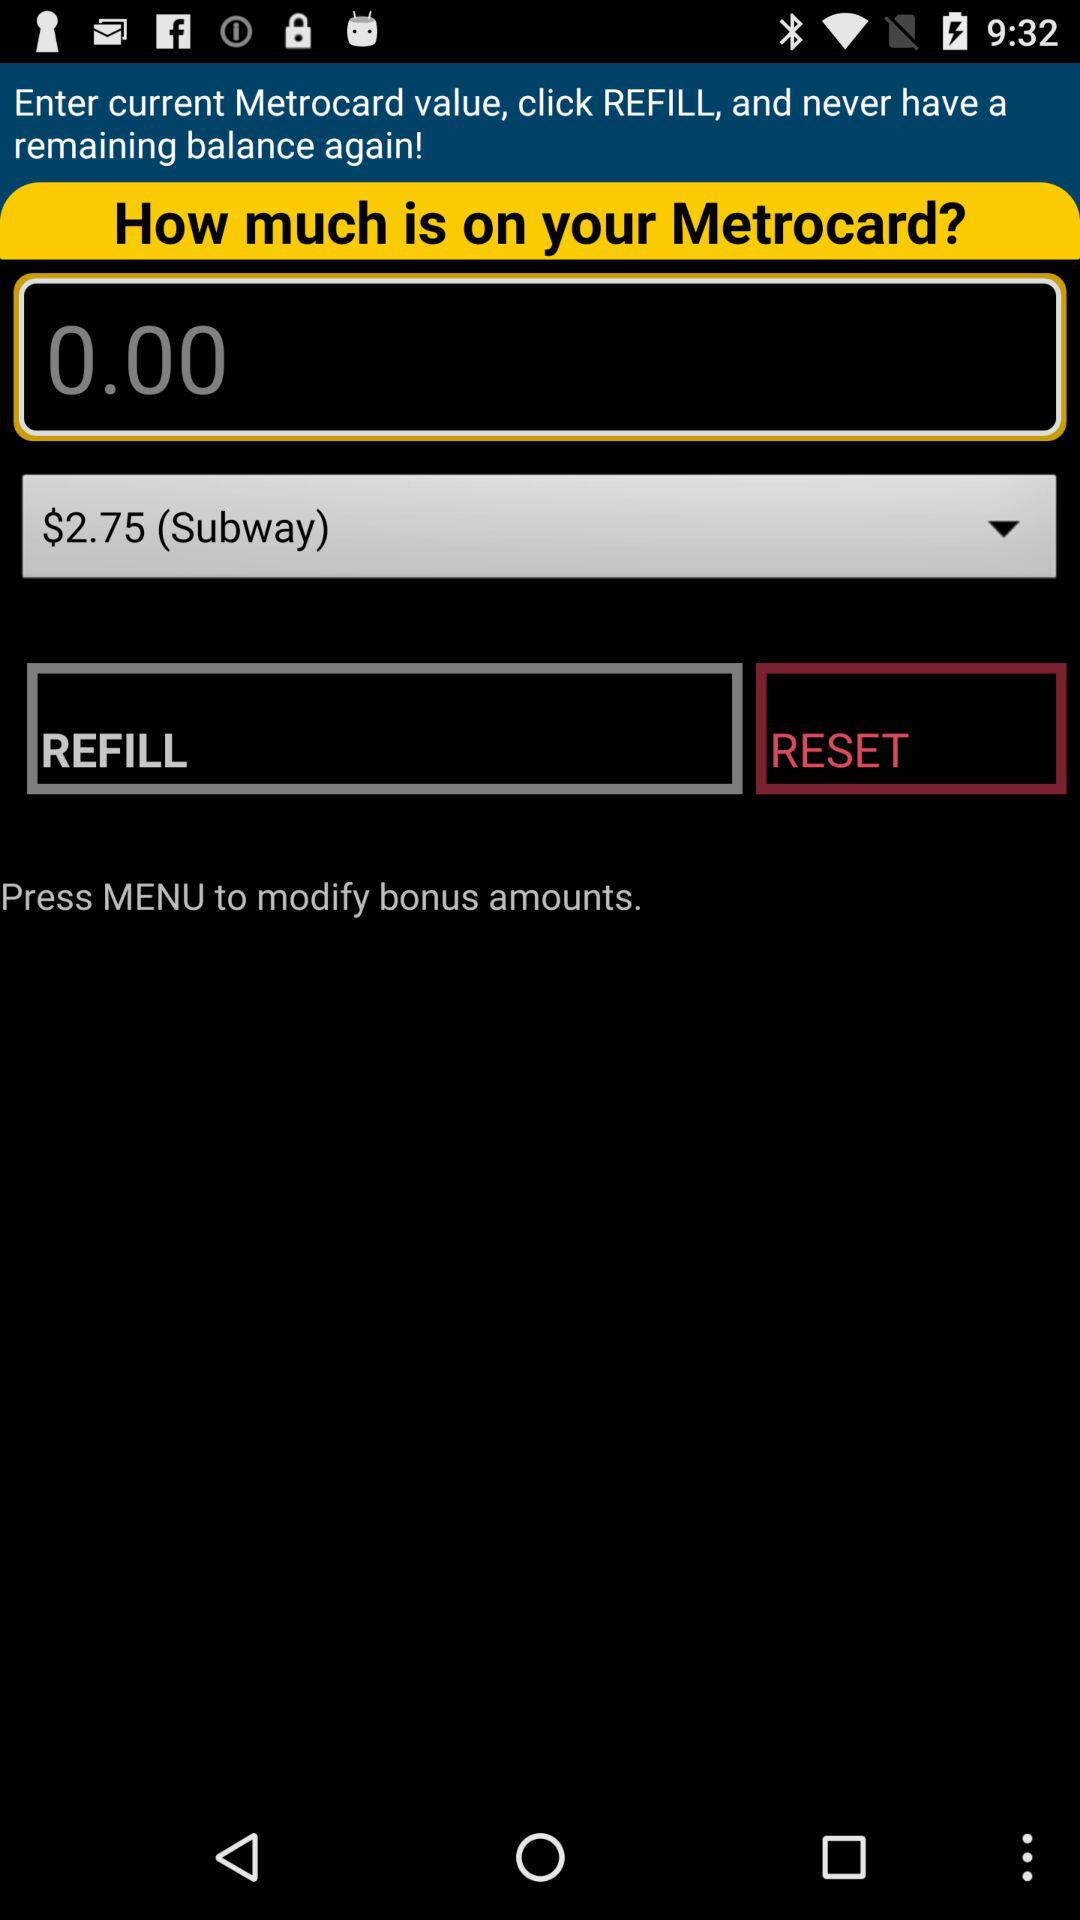What option should I select to reset? The option you should select to reset is "REFILL". 